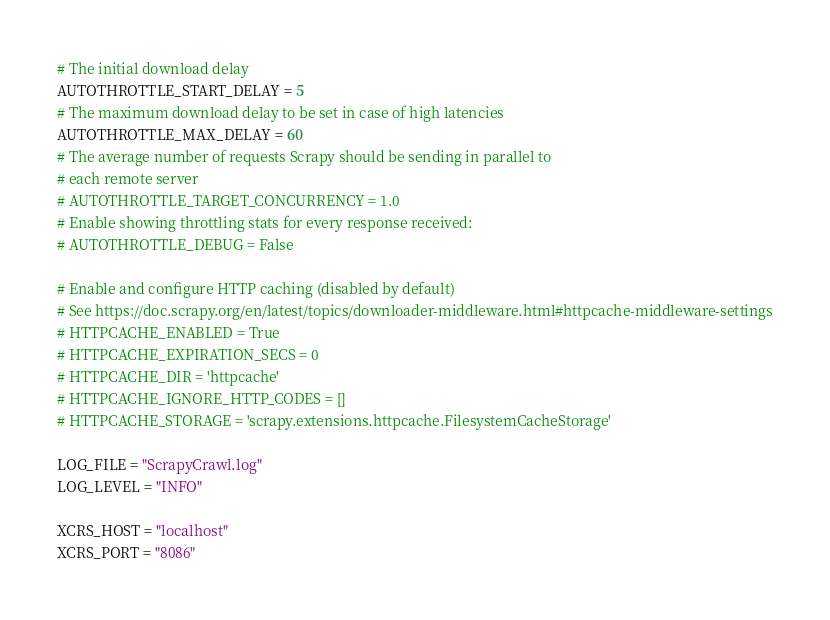<code> <loc_0><loc_0><loc_500><loc_500><_Python_># The initial download delay
AUTOTHROTTLE_START_DELAY = 5
# The maximum download delay to be set in case of high latencies
AUTOTHROTTLE_MAX_DELAY = 60
# The average number of requests Scrapy should be sending in parallel to
# each remote server
# AUTOTHROTTLE_TARGET_CONCURRENCY = 1.0
# Enable showing throttling stats for every response received:
# AUTOTHROTTLE_DEBUG = False

# Enable and configure HTTP caching (disabled by default)
# See https://doc.scrapy.org/en/latest/topics/downloader-middleware.html#httpcache-middleware-settings
# HTTPCACHE_ENABLED = True
# HTTPCACHE_EXPIRATION_SECS = 0
# HTTPCACHE_DIR = 'httpcache'
# HTTPCACHE_IGNORE_HTTP_CODES = []
# HTTPCACHE_STORAGE = 'scrapy.extensions.httpcache.FilesystemCacheStorage'

LOG_FILE = "ScrapyCrawl.log"
LOG_LEVEL = "INFO"

XCRS_HOST = "localhost"
XCRS_PORT = "8086"
</code> 